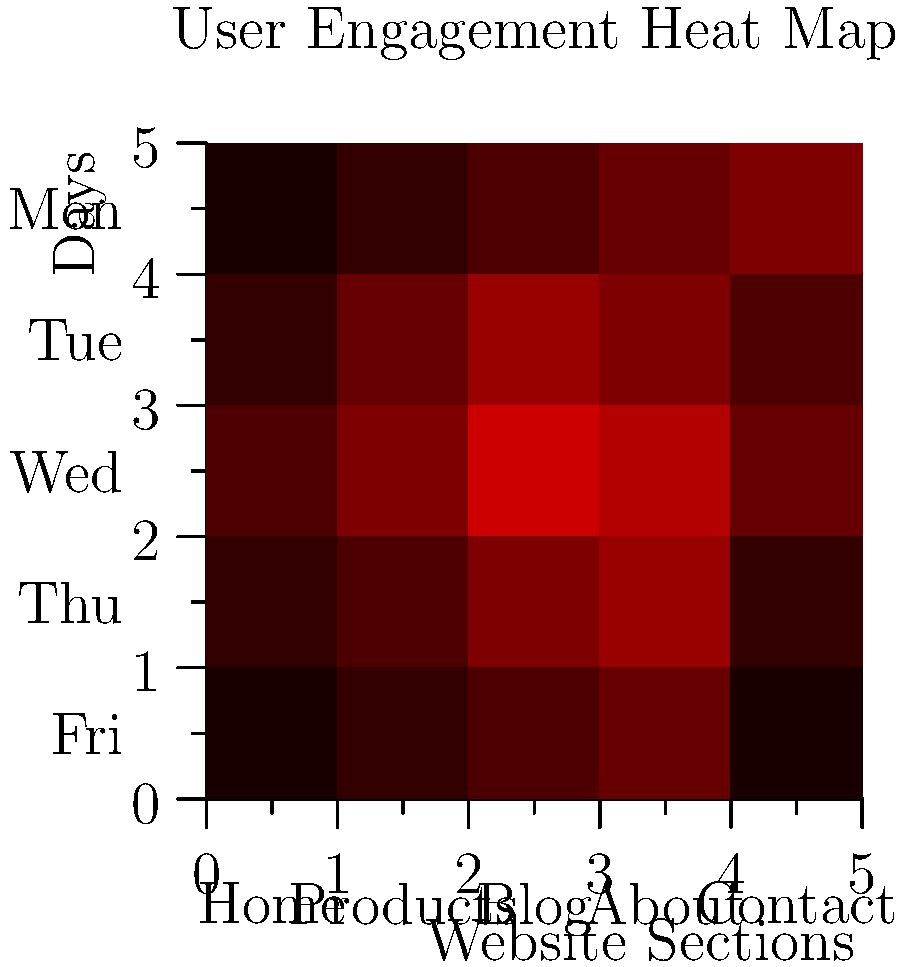Based on the heat map of user engagement across different website sections throughout the week, which section shows the highest engagement on Wednesday, and what strategy would you recommend to capitalize on this insight? To answer this question, we need to follow these steps:

1. Identify Wednesday's row in the heat map:
   - The y-axis represents days of the week from Monday to Friday.
   - Wednesday is the middle row (3rd from top or bottom).

2. Analyze the color intensity for Wednesday's row:
   - Darker red indicates higher engagement.
   - The darkest red square in the Wednesday row represents the highest engagement.

3. Determine the website section with the highest engagement:
   - Looking at the x-axis labels, we can see that the darkest red square aligns with the "Blog" section.

4. Interpret the data:
   - The Blog section has the highest user engagement on Wednesday.

5. Develop a strategy based on this insight:
   - Since the Blog shows peak engagement on Wednesday, we can:
     a) Schedule new blog post releases for Wednesday mornings.
     b) Promote important content or special offers through the blog on Wednesdays.
     c) Run targeted email campaigns on Tuesday evenings to drive traffic to the blog on Wednesday.
     d) Analyze the type of content that performs well on Wednesdays and create more similar content.

6. Consider cross-section opportunities:
   - Notice that the "Products" section also shows relatively high engagement on Wednesday.
   - We could create blog posts that highlight or review products to leverage both high-engagement areas.
Answer: Blog section; release new posts on Wednesdays, promote key content, and cross-link with product pages. 